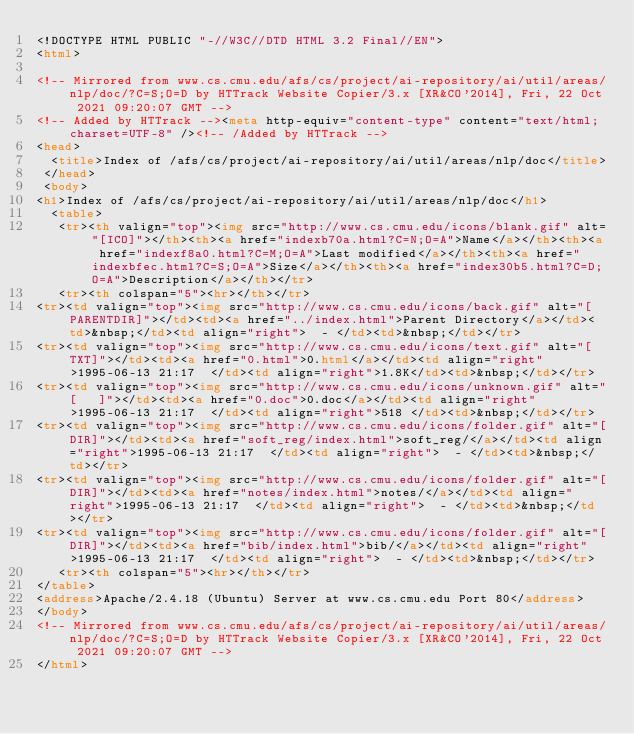<code> <loc_0><loc_0><loc_500><loc_500><_HTML_><!DOCTYPE HTML PUBLIC "-//W3C//DTD HTML 3.2 Final//EN">
<html>
 
<!-- Mirrored from www.cs.cmu.edu/afs/cs/project/ai-repository/ai/util/areas/nlp/doc/?C=S;O=D by HTTrack Website Copier/3.x [XR&CO'2014], Fri, 22 Oct 2021 09:20:07 GMT -->
<!-- Added by HTTrack --><meta http-equiv="content-type" content="text/html;charset=UTF-8" /><!-- /Added by HTTrack -->
<head>
  <title>Index of /afs/cs/project/ai-repository/ai/util/areas/nlp/doc</title>
 </head>
 <body>
<h1>Index of /afs/cs/project/ai-repository/ai/util/areas/nlp/doc</h1>
  <table>
   <tr><th valign="top"><img src="http://www.cs.cmu.edu/icons/blank.gif" alt="[ICO]"></th><th><a href="indexb70a.html?C=N;O=A">Name</a></th><th><a href="indexf8a0.html?C=M;O=A">Last modified</a></th><th><a href="indexbfec.html?C=S;O=A">Size</a></th><th><a href="index30b5.html?C=D;O=A">Description</a></th></tr>
   <tr><th colspan="5"><hr></th></tr>
<tr><td valign="top"><img src="http://www.cs.cmu.edu/icons/back.gif" alt="[PARENTDIR]"></td><td><a href="../index.html">Parent Directory</a></td><td>&nbsp;</td><td align="right">  - </td><td>&nbsp;</td></tr>
<tr><td valign="top"><img src="http://www.cs.cmu.edu/icons/text.gif" alt="[TXT]"></td><td><a href="0.html">0.html</a></td><td align="right">1995-06-13 21:17  </td><td align="right">1.8K</td><td>&nbsp;</td></tr>
<tr><td valign="top"><img src="http://www.cs.cmu.edu/icons/unknown.gif" alt="[   ]"></td><td><a href="0.doc">0.doc</a></td><td align="right">1995-06-13 21:17  </td><td align="right">518 </td><td>&nbsp;</td></tr>
<tr><td valign="top"><img src="http://www.cs.cmu.edu/icons/folder.gif" alt="[DIR]"></td><td><a href="soft_reg/index.html">soft_reg/</a></td><td align="right">1995-06-13 21:17  </td><td align="right">  - </td><td>&nbsp;</td></tr>
<tr><td valign="top"><img src="http://www.cs.cmu.edu/icons/folder.gif" alt="[DIR]"></td><td><a href="notes/index.html">notes/</a></td><td align="right">1995-06-13 21:17  </td><td align="right">  - </td><td>&nbsp;</td></tr>
<tr><td valign="top"><img src="http://www.cs.cmu.edu/icons/folder.gif" alt="[DIR]"></td><td><a href="bib/index.html">bib/</a></td><td align="right">1995-06-13 21:17  </td><td align="right">  - </td><td>&nbsp;</td></tr>
   <tr><th colspan="5"><hr></th></tr>
</table>
<address>Apache/2.4.18 (Ubuntu) Server at www.cs.cmu.edu Port 80</address>
</body>
<!-- Mirrored from www.cs.cmu.edu/afs/cs/project/ai-repository/ai/util/areas/nlp/doc/?C=S;O=D by HTTrack Website Copier/3.x [XR&CO'2014], Fri, 22 Oct 2021 09:20:07 GMT -->
</html>
</code> 